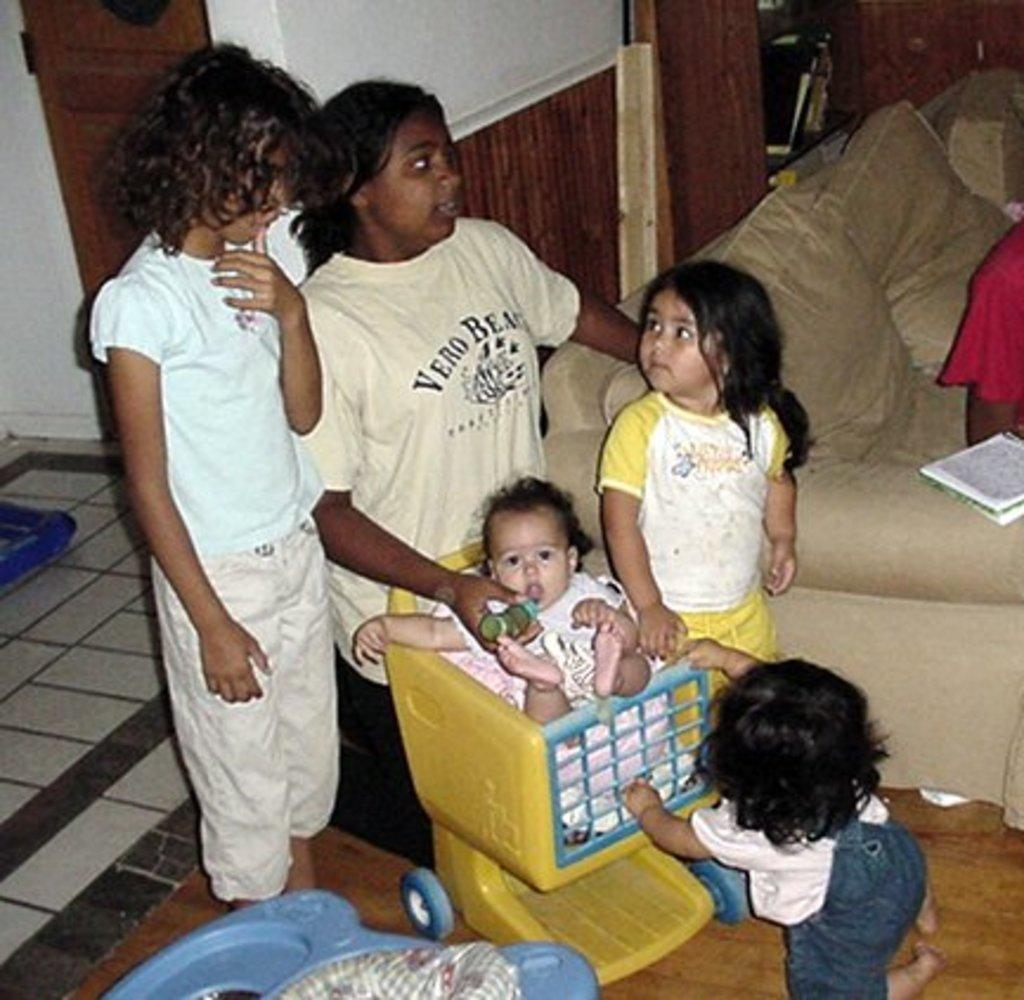What is happening in the center of the image? There are persons standing in the center of the image. What are the persons doing near the baby? They are standing near a baby. What can be seen in the background of the image? There is a bed, pillows, a door, and a wall in the background of the image. How many ladybugs are crawling on the legs of the persons in the image? There are no ladybugs present in the image, and the legs of the persons are not visible. 